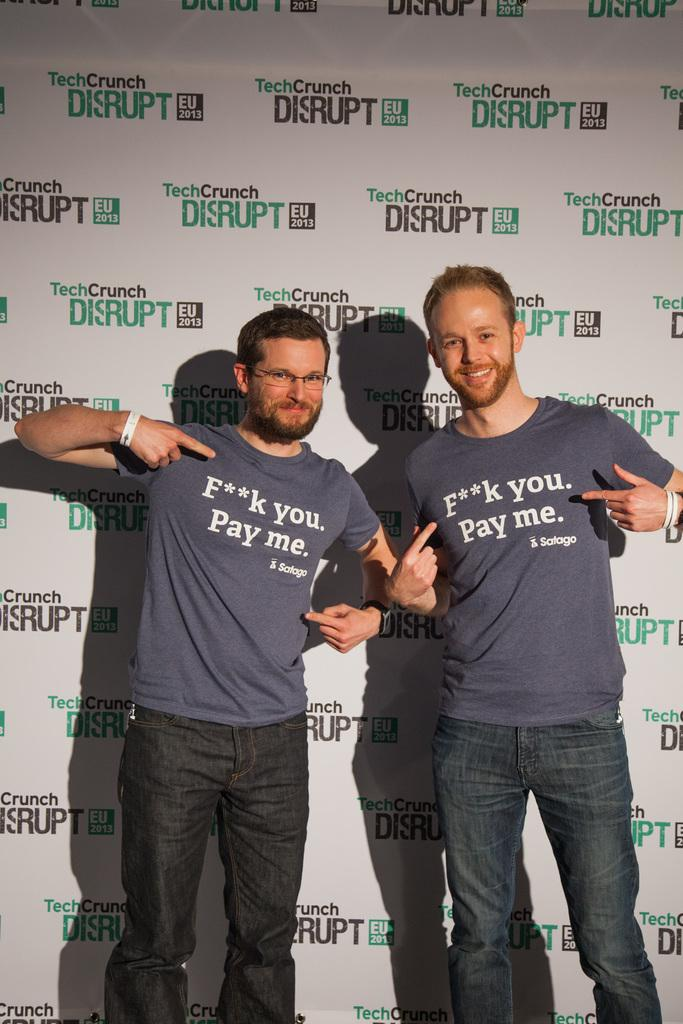What is happening in the center of the image? There are men standing in the center of the image. What is the surface on which the men are standing? The men are standing on the floor. What can be seen in the background of the image? There is an advertisement visible in the background of the image. What type of rings can be seen on the men's fingers in the image? There are no rings visible on the men's fingers in the image. What time does the watch on the man's wrist display in the image? There is no watch visible on the men's wrists in the image. 